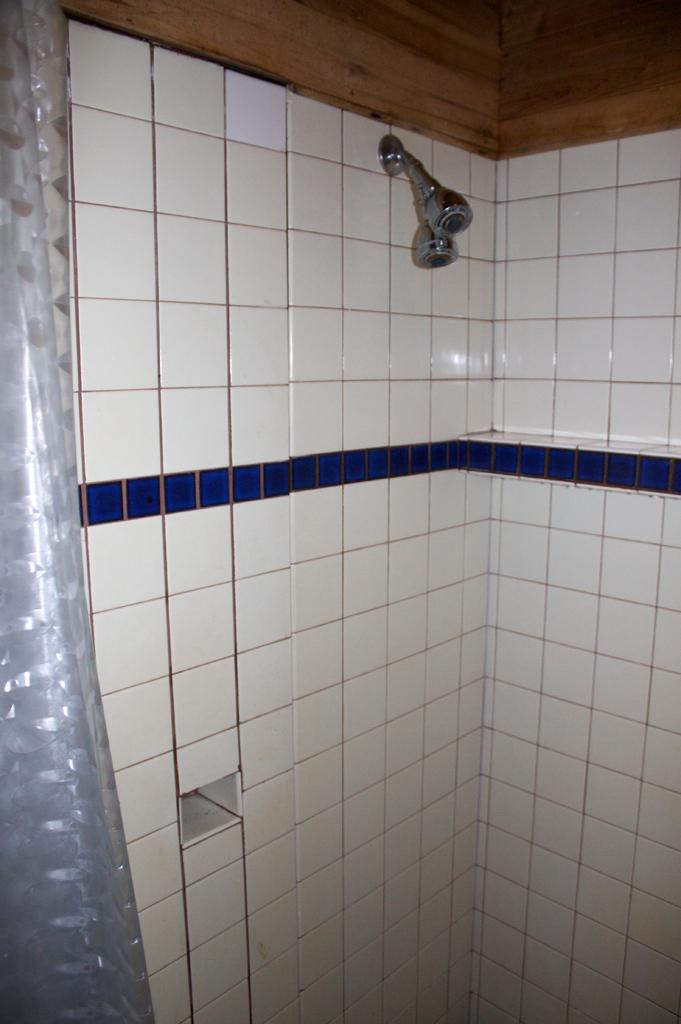What can be seen at the top side of the image? There are showers at the top side of the image. What is located on the left side of the image? There appears to be a curtain on the left side of the image. Where is the key used to open the farm gate in the image? There is no key or farm gate present in the image. What type of coal is being used to heat the showers in the image? There is no coal present in the image, and the showers are not being heated. 